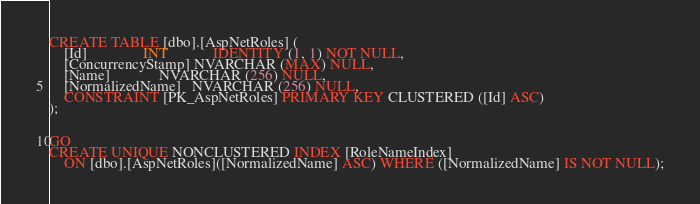Convert code to text. <code><loc_0><loc_0><loc_500><loc_500><_SQL_>CREATE TABLE [dbo].[AspNetRoles] (
    [Id]               INT            IDENTITY (1, 1) NOT NULL,
    [ConcurrencyStamp] NVARCHAR (MAX) NULL,
    [Name]             NVARCHAR (256) NULL,
    [NormalizedName]   NVARCHAR (256) NULL,
    CONSTRAINT [PK_AspNetRoles] PRIMARY KEY CLUSTERED ([Id] ASC)
);


GO
CREATE UNIQUE NONCLUSTERED INDEX [RoleNameIndex]
    ON [dbo].[AspNetRoles]([NormalizedName] ASC) WHERE ([NormalizedName] IS NOT NULL);

</code> 